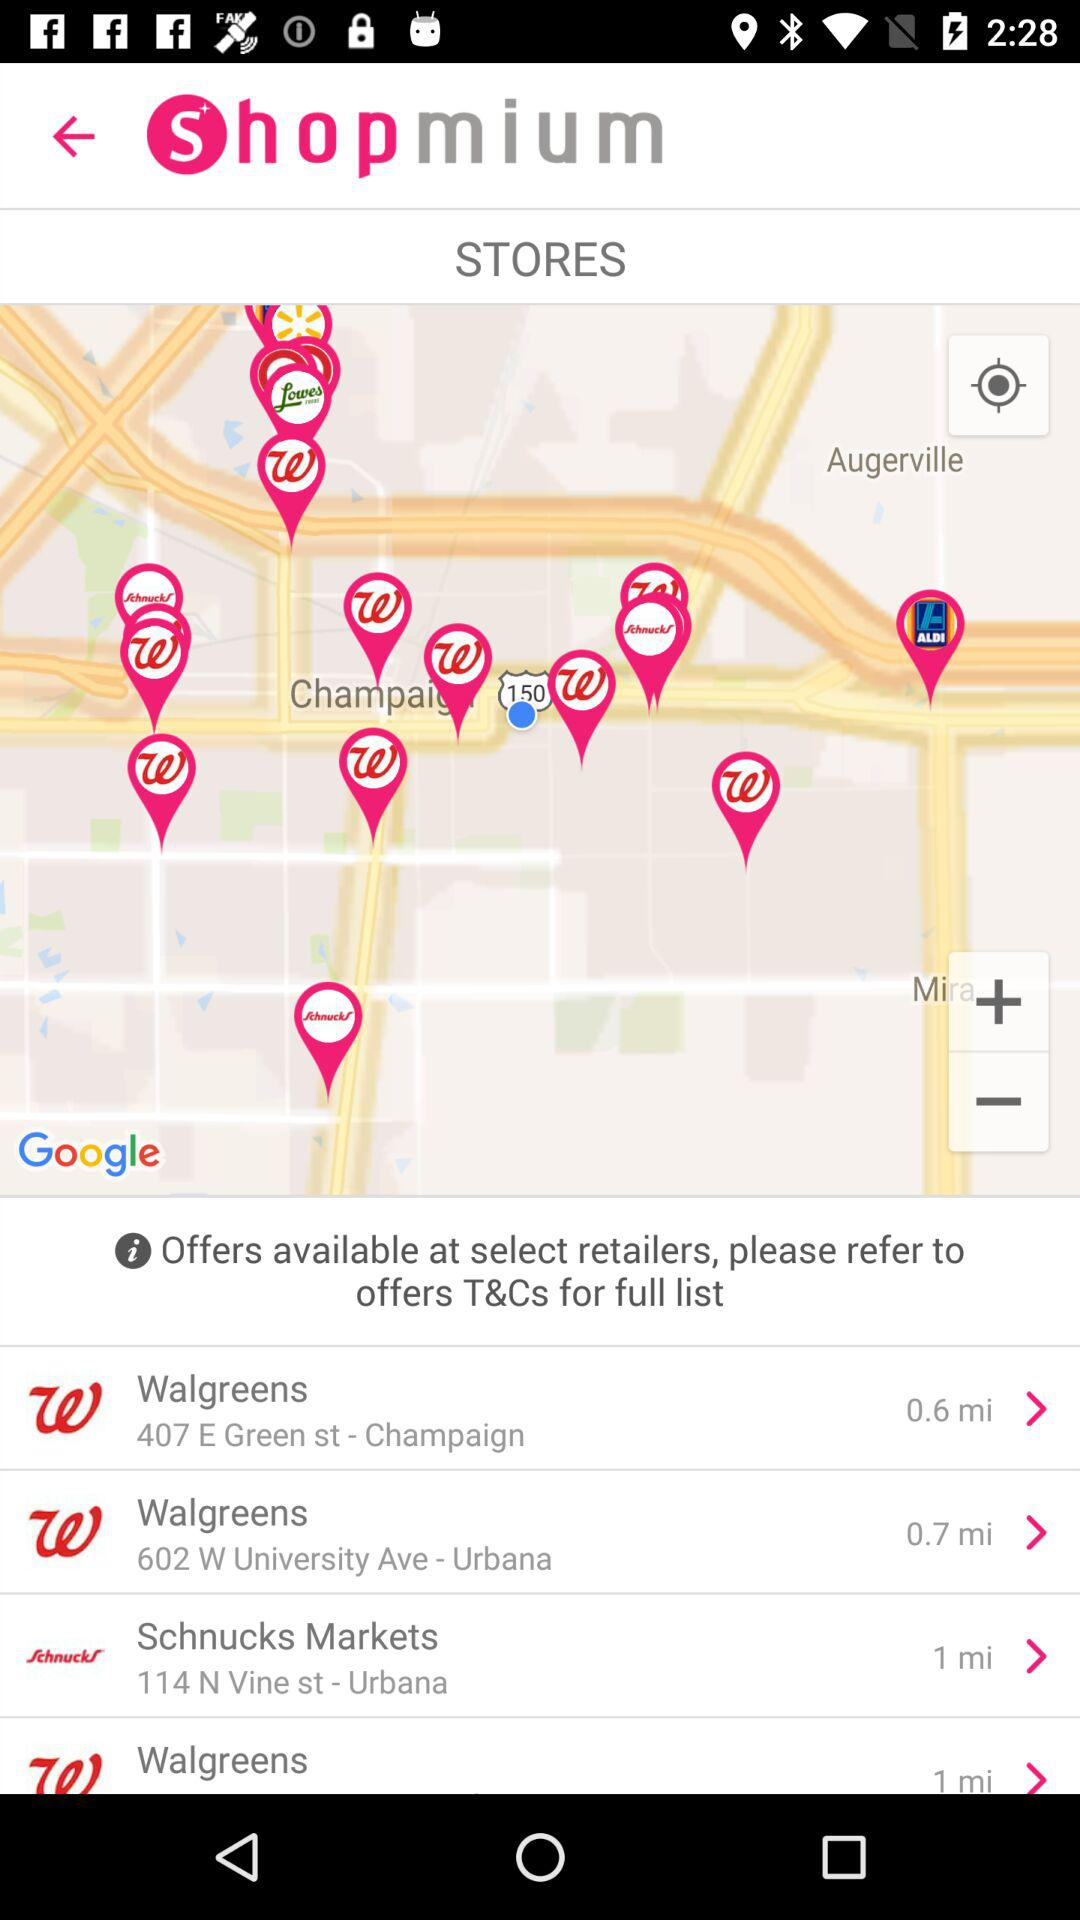What is the location of "Schnucks Markets"? The location of "Schnucks Markets" is 114 N Vine st - Urbana. 